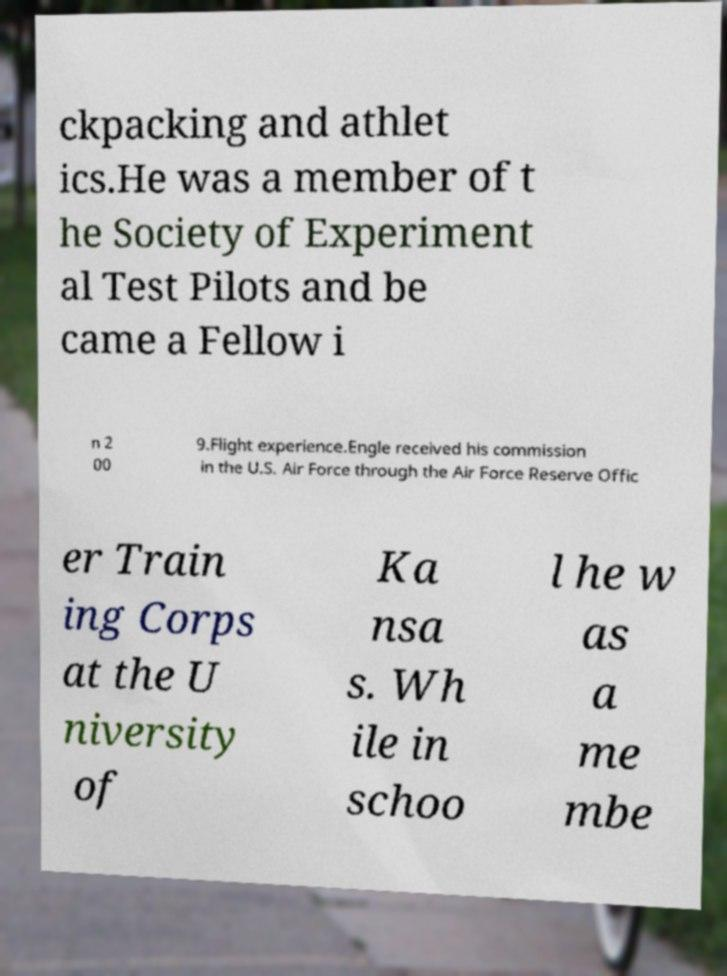Please identify and transcribe the text found in this image. ckpacking and athlet ics.He was a member of t he Society of Experiment al Test Pilots and be came a Fellow i n 2 00 9.Flight experience.Engle received his commission in the U.S. Air Force through the Air Force Reserve Offic er Train ing Corps at the U niversity of Ka nsa s. Wh ile in schoo l he w as a me mbe 